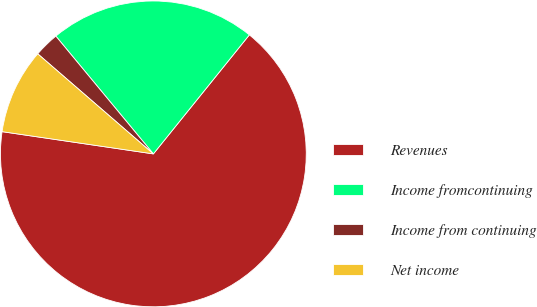Convert chart. <chart><loc_0><loc_0><loc_500><loc_500><pie_chart><fcel>Revenues<fcel>Income fromcontinuing<fcel>Income from continuing<fcel>Net income<nl><fcel>66.52%<fcel>21.81%<fcel>2.64%<fcel>9.03%<nl></chart> 